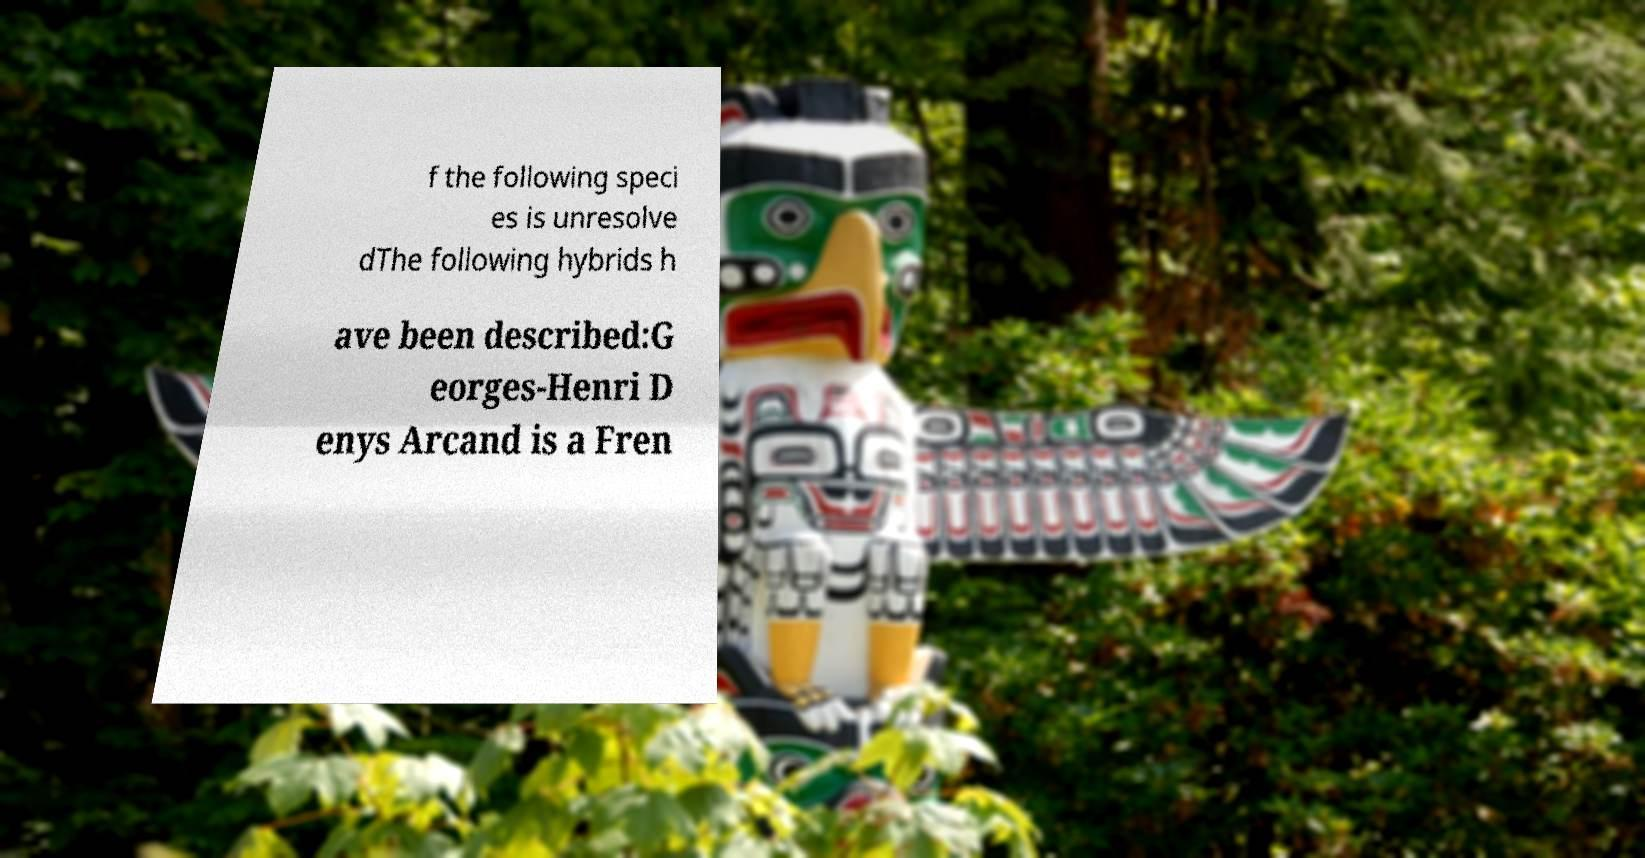Please identify and transcribe the text found in this image. f the following speci es is unresolve dThe following hybrids h ave been described:G eorges-Henri D enys Arcand is a Fren 